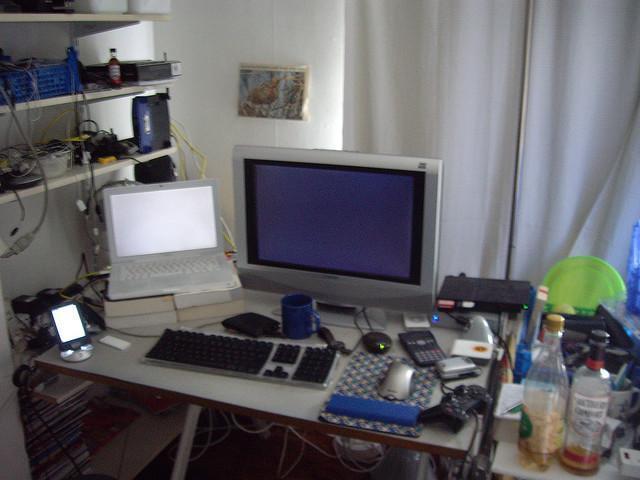How many computers are there?
Give a very brief answer. 2. How many bottles can you see?
Give a very brief answer. 2. 